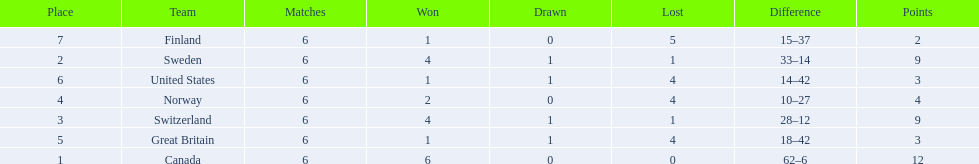What are the names of the countries? Canada, Sweden, Switzerland, Norway, Great Britain, United States, Finland. How many wins did switzerland have? 4. How many wins did great britain have? 1. Which country had more wins, great britain or switzerland? Switzerland. 